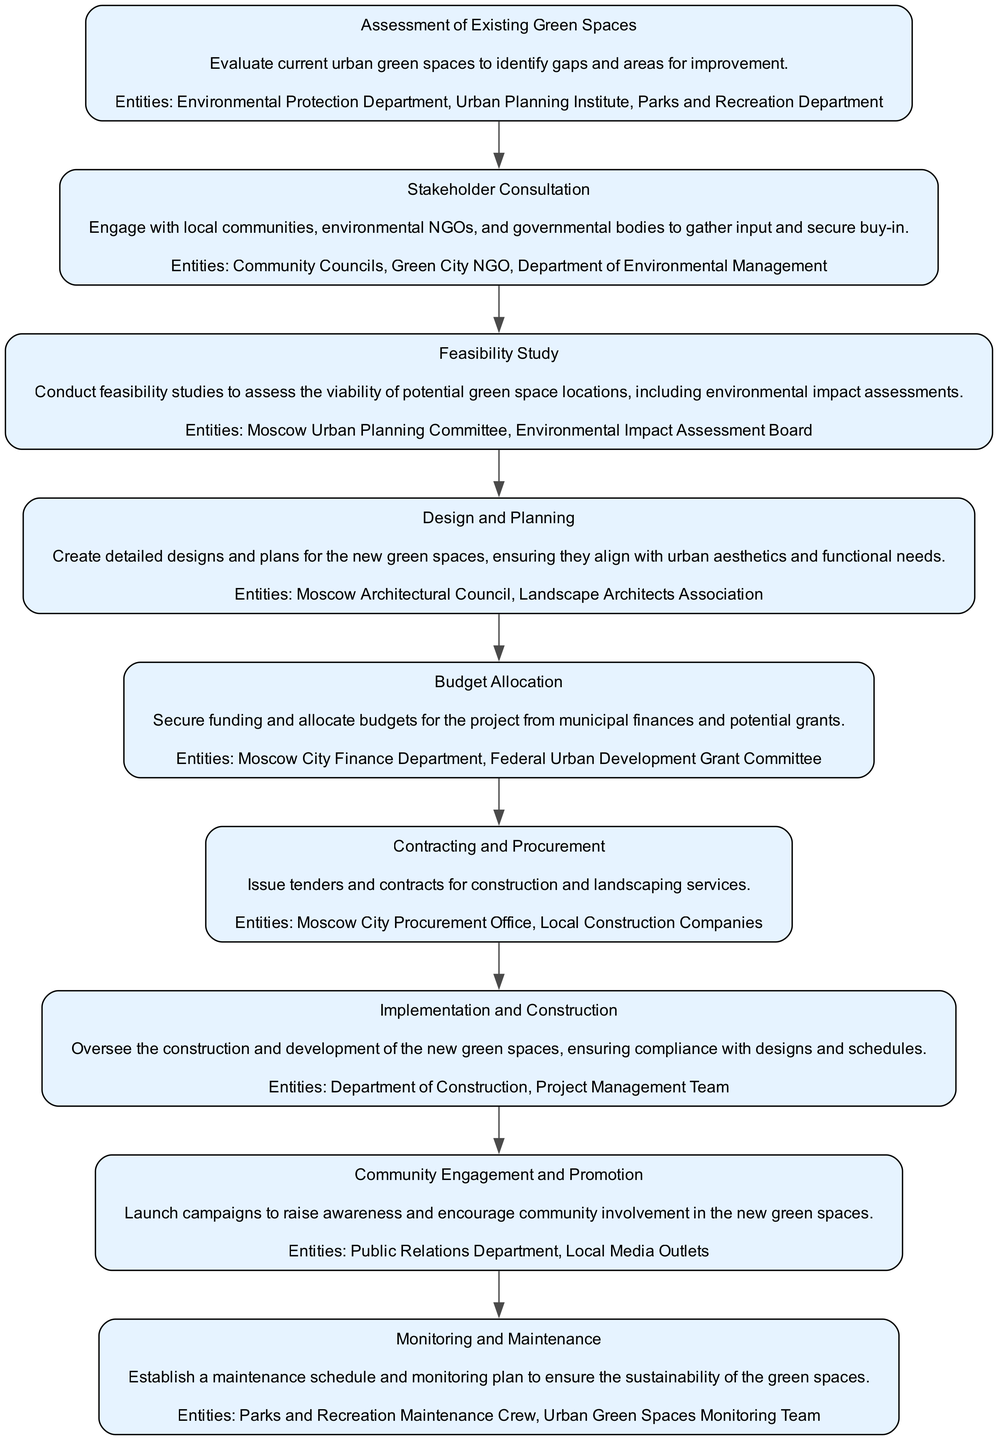What is the first step in the initiative? The first step listed in the diagram is "Assessment of Existing Green Spaces." This is indicated at the top of the flowchart as the starting node, which shows the initial action in the process.
Answer: Assessment of Existing Green Spaces How many total steps are there in the initiative? By counting the nodes in the flowchart, there are a total of nine distinct steps outlined in the initiative, as each node corresponds to a specific step.
Answer: 9 What entities are involved in the "Design and Planning" step? The entities involved in this step can be found in the corresponding node, which lists "Moscow Architectural Council" and "Landscape Architects Association" as key players in this phase of the initiative.
Answer: Moscow Architectural Council, Landscape Architects Association Which step comes after "Feasibility Study"? Based on the sequential arrangement in the flowchart, the step that directly follows "Feasibility Study" is "Design and Planning," indicating the progression from assessment to implementation.
Answer: Design and Planning What is the main purpose of the "Community Engagement and Promotion" step? By looking at the description in the node, the primary purpose is to "launch campaigns to raise awareness and encourage community involvement," which highlights its role in connecting with the public on the initiative.
Answer: Launch campaigns to raise awareness What two departments are involved in the "Monitoring and Maintenance" step? In the node for this step, the involved entities are specifically listed as "Parks and Recreation Maintenance Crew" and "Urban Green Spaces Monitoring Team," signifying their responsibilities in this phase.
Answer: Parks and Recreation Maintenance Crew, Urban Green Spaces Monitoring Team What kind of study is conducted during the "Feasibility Study"? The flowchart specifies that the "Feasibility Study" involves "feasibility studies to assess the viability of potential green space locations," indicating the type of assessment carried out in this step.
Answer: Feasibility studies What is the last step of the initiative? The final step in the sequence, as indicated by the last node in the flowchart, is "Monitoring and Maintenance," which signifies ongoing care for the new green spaces after their establishment.
Answer: Monitoring and Maintenance What is the purpose of involving "Community Councils" in the process? "Community Councils" are engaged during the "Stakeholder Consultation" to gather input and secure buy-in, which is crucial for ensuring community support for the initiative.
Answer: Gather input and secure buy-in 